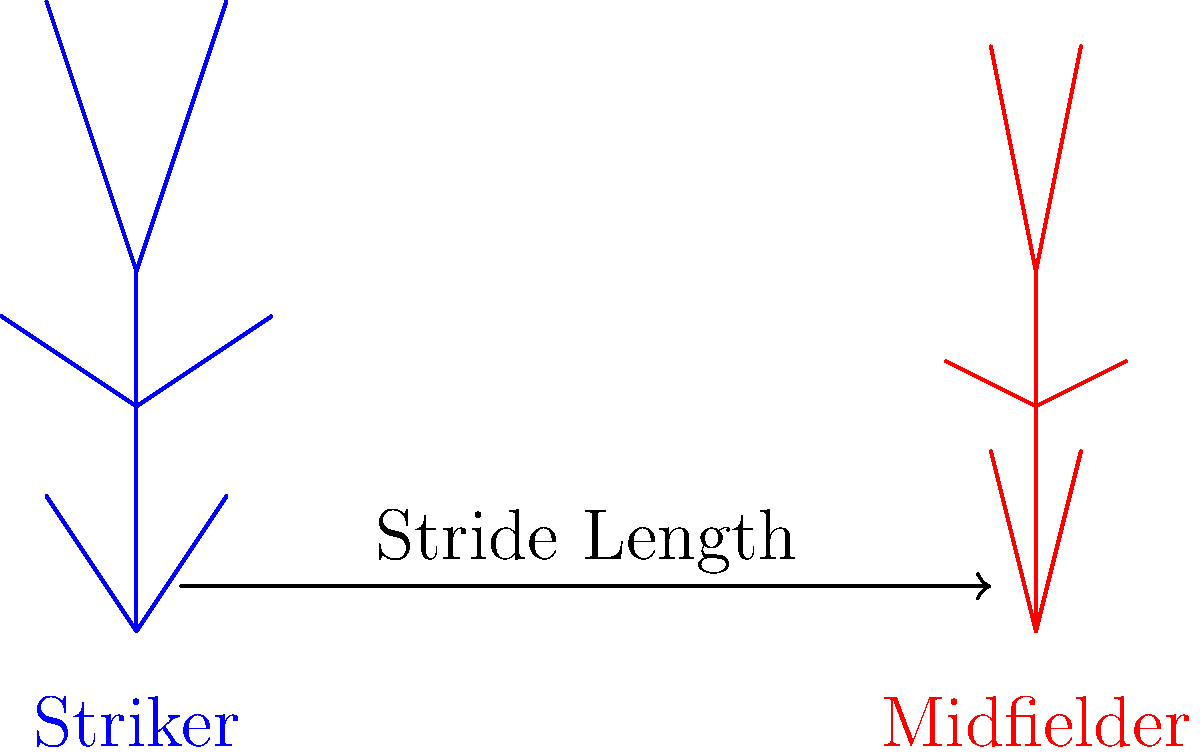Based on the stick figure representation of a striker (like Diego Costa) and a midfielder in the EPL, what key difference in running gait can be observed, and how might this impact their performance on the pitch? To answer this question, let's analyze the stick figure representation step-by-step:

1. Stride Length: The arrow between the two figures indicates the stride length. The striker's stance is wider, suggesting a longer stride.

2. Body Posture: 
   - Striker: More upright posture, with a slightly backward lean.
   - Midfielder: Slightly forward-leaning posture.

3. Arm Position:
   - Striker: Arms are more extended, indicating a more powerful arm swing.
   - Midfielder: Arms are closer to the body, suggesting a more compact running style.

4. Leg Position:
   - Striker: Legs are more extended, both in the stance and swing phase.
   - Midfielder: Legs show a higher knee lift and a more compact stride.

The key difference observed is the stride length and overall body posture. Strikers like Diego Costa tend to have longer strides and a more upright posture, which allows for:

a) Faster acceleration over short distances
b) More explosive movements when breaking away from defenders

Midfielders, with their shorter strides and forward-leaning posture, are optimized for:

a) Quick changes in direction
b) Sustained running throughout the match
c) Better ball control while running

This difference in running gait impacts their performance by allowing strikers to excel in explosive sprints for scoring opportunities, while midfielders can maintain consistent movement and ball control throughout the match.
Answer: Longer stride length and upright posture for strikers; shorter, more compact stride for midfielders. 